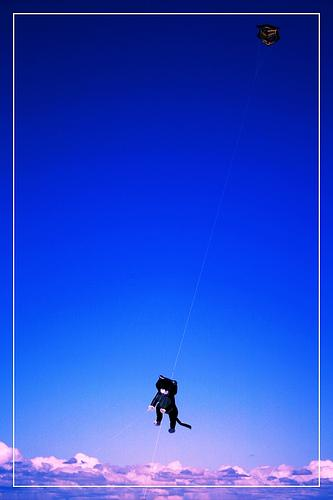Explain the main subject of the image along with its action and background. A black and white stuffed cat with white strings on its paws flies through a clear blue sky above purple and white clouds, tethered to a floating kite. Use metaphors or similes to describe the image in a creative way. Swift as a running river, the black feline defies gravity, its white paws clenching the white strings that anchor it to the sky like a floating kite, sailing amidst a sea of blue and white. Mention the most striking elements of the scene in a single sentence. A black cat with white paws clutches white strings attached to a badge-shaped black and yellow kite, floating high in a bright blue sky. Write a haiku inspired by the image's contents. Kite floats on the breeze. Tell us what you find most unusual in the image and describe it briefly. A seemingly stuffed cat dressed as a skydiver flies in the blue sky, holding onto white strings connected to a yellow and black kite above the clouds. Provide a detailed description of the central object in the image and its appearance. The image features a large black cat with white paws, a white snout, and long black tail, holding onto white strings and appearing to float in the sky. Create an alliterative sentence explaining the main subject of the image. A bewitching black-and-white cat clutches captivating cords, cruising high above cotton-clouds beneath the bold, blue expanse of sky. Summarize what's happening in the image by focusing on the key subject and its action. A large stuffed black cat with white paws and snout clings onto white strings attached to a kite, appearing to fly gracefully in the clear blue sky. Narrate what you visualize in the image using a poetic language style. A majestic black feline hovers aloft in the azure heavens, its black tail swirling amidst white puff clouds, as it grasps silken cords tethered to a vibrant kite. Imagine you're describing the scene to someone who cannot see the image; create a vivid, detailed description. Imagine a fluffy black cat soaring in the sky, gripping white strings with its paws, suspended from a multi-colored kite floating high above a backdrop of blue skies and puffy white clouds. Observe the moon shining bright in the clear blue sky. No, it's not mentioned in the image. The cat has wings that enable it to fly. The captions describe a cat being held by strings and doesn't mention wings in any caption. This instruction might make the viewer believe something false about the image. Notice how the person riding the kite is trying to catch the cat. There is no mention of a person riding the kite or attempting to catch the cat. Is the black cat actually blue? The black cat is described as "black" in multiple captions, so stating it as blue may mislead the viewer to think there is a different cat or a mistake in the image annotation. Find the person holding the white strings that pull the cat into the sky. There is no mention of a person holding the strings in the captions. This instruction may make the viewer search for a non-existent element in the image. There's a big red balloon floating next to the clouds. No mention of red balloons exists in the captions. This instruction would lead the viewer to seek out an object that is not there. The strings on the cat are actually long snakes wrapped around its paws. There's no mention of snakes in the captions, only strings. This instruction may introduce incorrect and misleading information to the viewer. The white clouds are actually thick smoke from a fire in the background. The captions mention clouds with different colors but do not describe any smoke or fire. This instruction may introduce a false narrative about the image. Can you see a cat holding a brown umbrella? The captions do not mention a brown umbrella being held by the cat. This instruction would mislead the viewer into looking for something not present in the image. Look for an orange cloud at the bottom of the image. There are captions mentioning purple and white clouds, but no mention of orange clouds. By suggesting an orange cloud, the viewer might be misled to search for something that does not exist. 